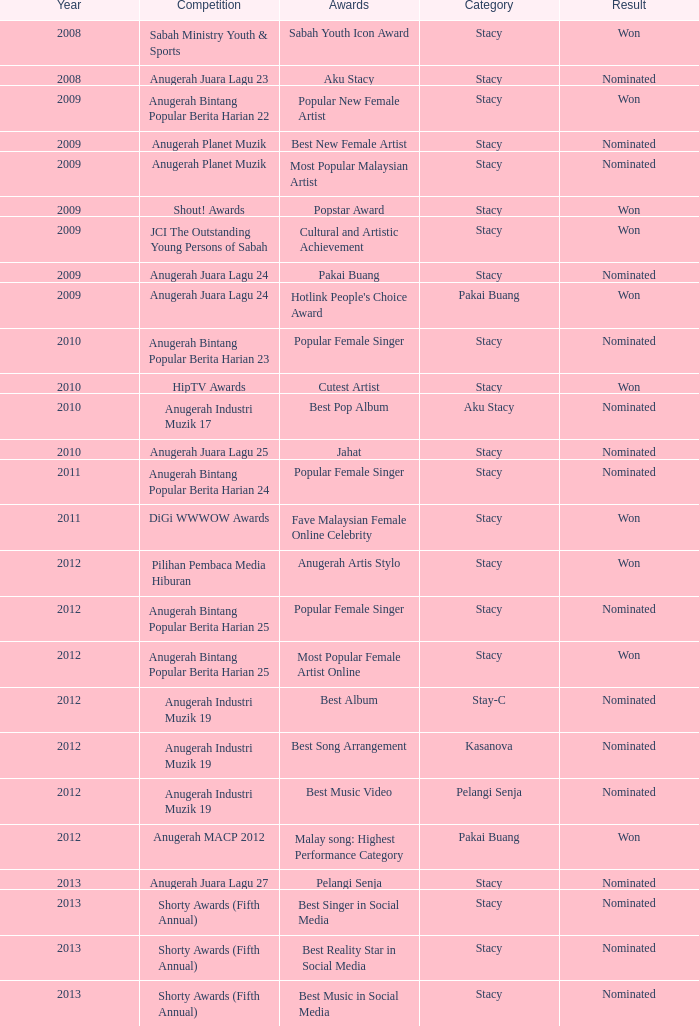For the years beyond 2008, what was the achievement in the stacy category with a jahat award? Nominated. 